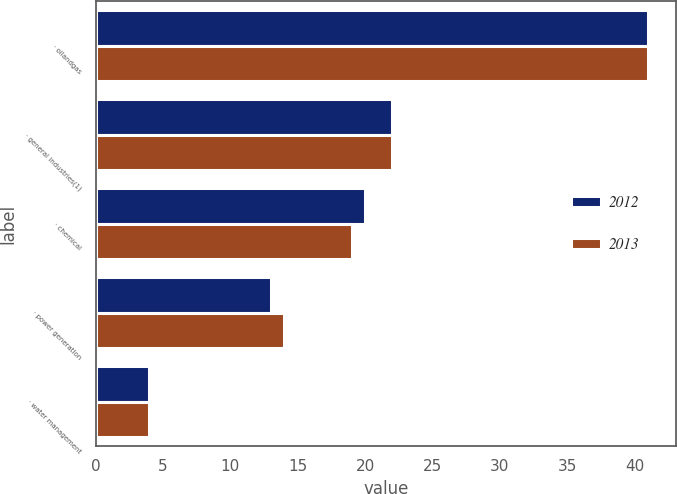Convert chart. <chart><loc_0><loc_0><loc_500><loc_500><stacked_bar_chart><ecel><fcel>· oilandgas<fcel>· general industries(1)<fcel>· chemical<fcel>· power generation<fcel>· water management<nl><fcel>2012<fcel>41<fcel>22<fcel>20<fcel>13<fcel>4<nl><fcel>2013<fcel>41<fcel>22<fcel>19<fcel>14<fcel>4<nl></chart> 